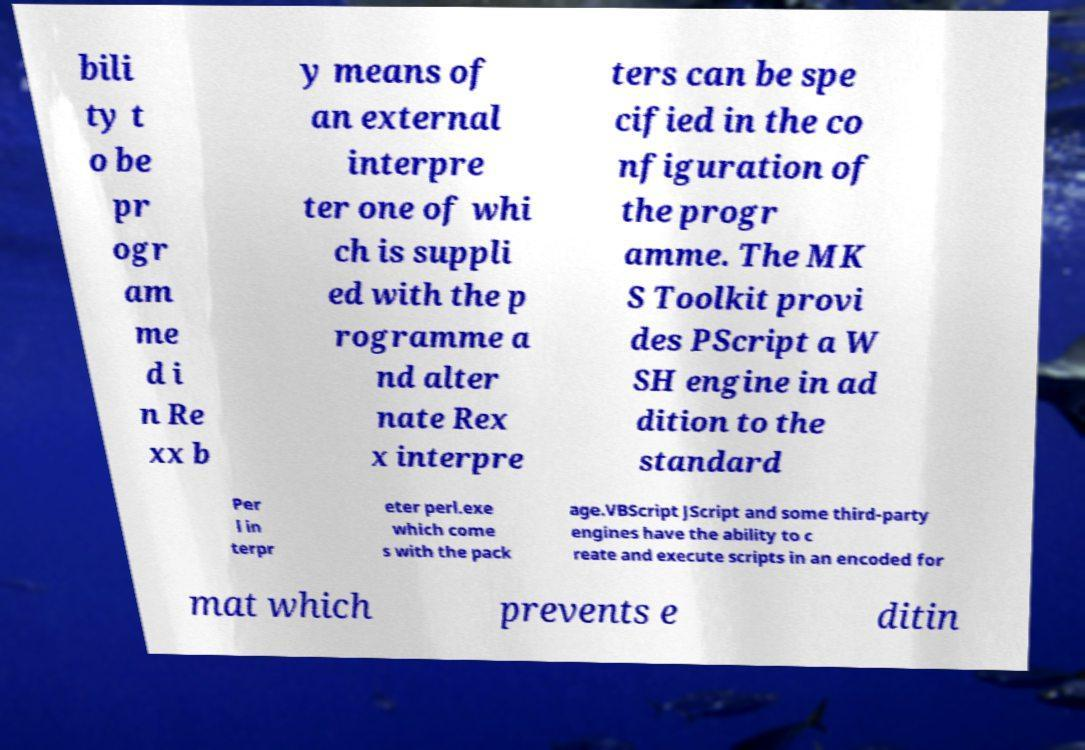There's text embedded in this image that I need extracted. Can you transcribe it verbatim? bili ty t o be pr ogr am me d i n Re xx b y means of an external interpre ter one of whi ch is suppli ed with the p rogramme a nd alter nate Rex x interpre ters can be spe cified in the co nfiguration of the progr amme. The MK S Toolkit provi des PScript a W SH engine in ad dition to the standard Per l in terpr eter perl.exe which come s with the pack age.VBScript JScript and some third-party engines have the ability to c reate and execute scripts in an encoded for mat which prevents e ditin 